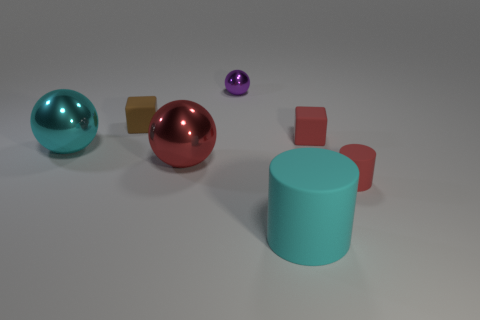Add 2 red things. How many objects exist? 9 Subtract all red balls. How many balls are left? 2 Subtract all tiny brown spheres. Subtract all large rubber things. How many objects are left? 6 Add 2 red spheres. How many red spheres are left? 3 Add 7 cyan cylinders. How many cyan cylinders exist? 8 Subtract all cyan cylinders. How many cylinders are left? 1 Subtract 0 blue balls. How many objects are left? 7 Subtract all cylinders. How many objects are left? 5 Subtract 1 cylinders. How many cylinders are left? 1 Subtract all green cubes. Subtract all blue cylinders. How many cubes are left? 2 